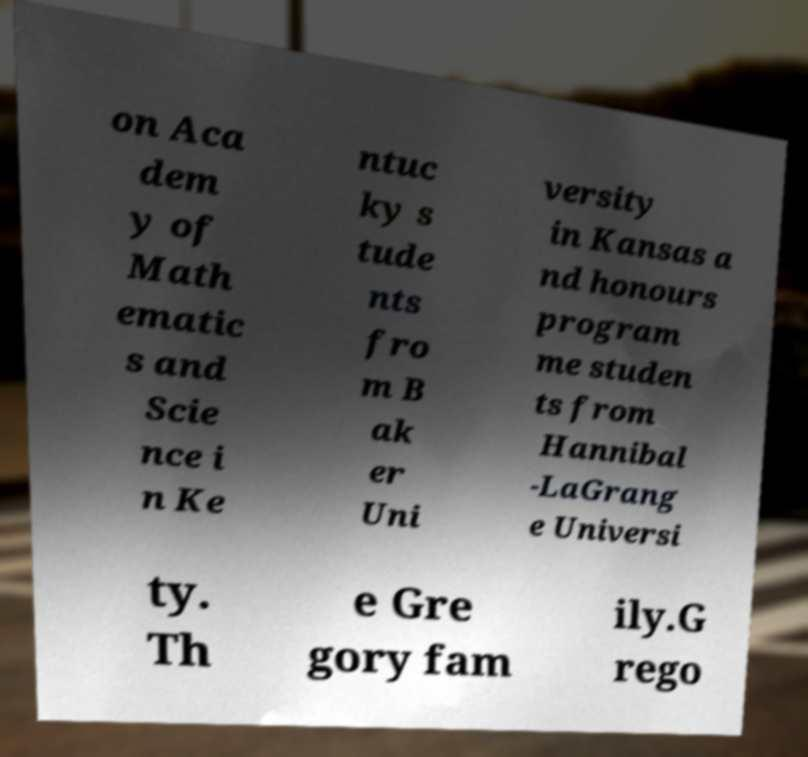Can you read and provide the text displayed in the image?This photo seems to have some interesting text. Can you extract and type it out for me? on Aca dem y of Math ematic s and Scie nce i n Ke ntuc ky s tude nts fro m B ak er Uni versity in Kansas a nd honours program me studen ts from Hannibal -LaGrang e Universi ty. Th e Gre gory fam ily.G rego 